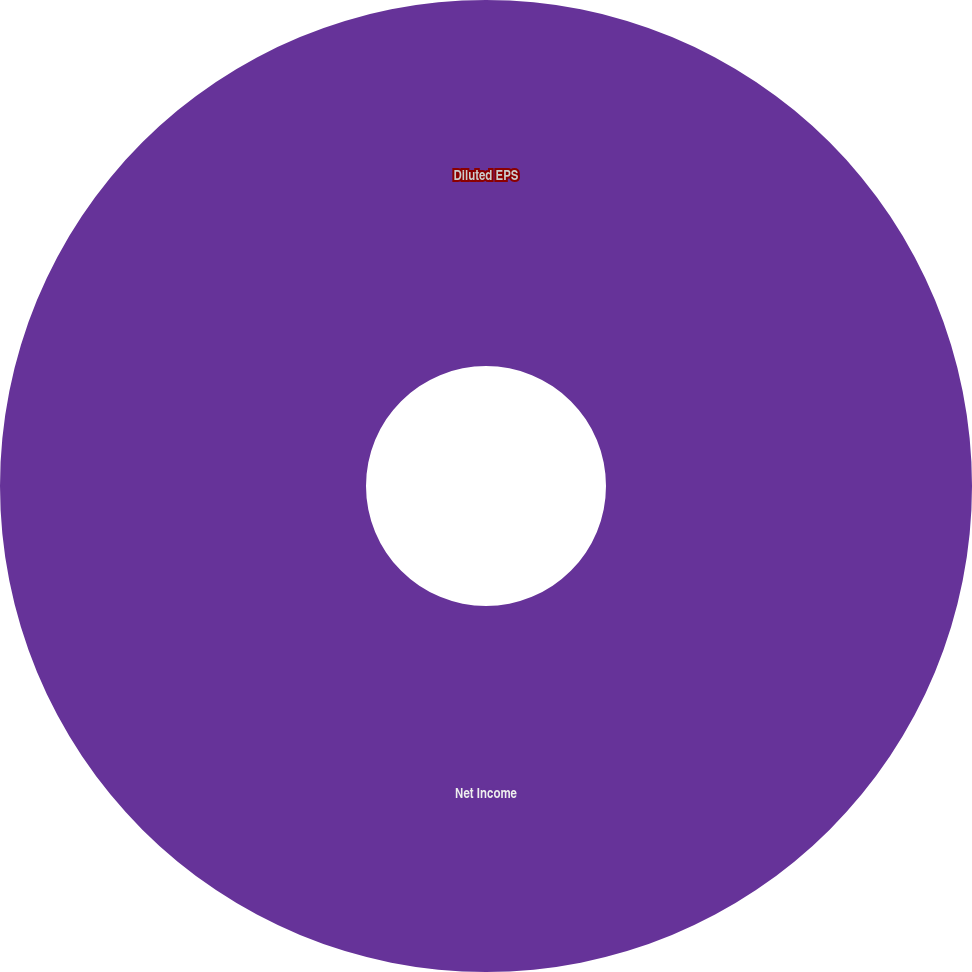Convert chart to OTSL. <chart><loc_0><loc_0><loc_500><loc_500><pie_chart><fcel>Net Income<fcel>Diluted EPS<nl><fcel>100.0%<fcel>0.0%<nl></chart> 